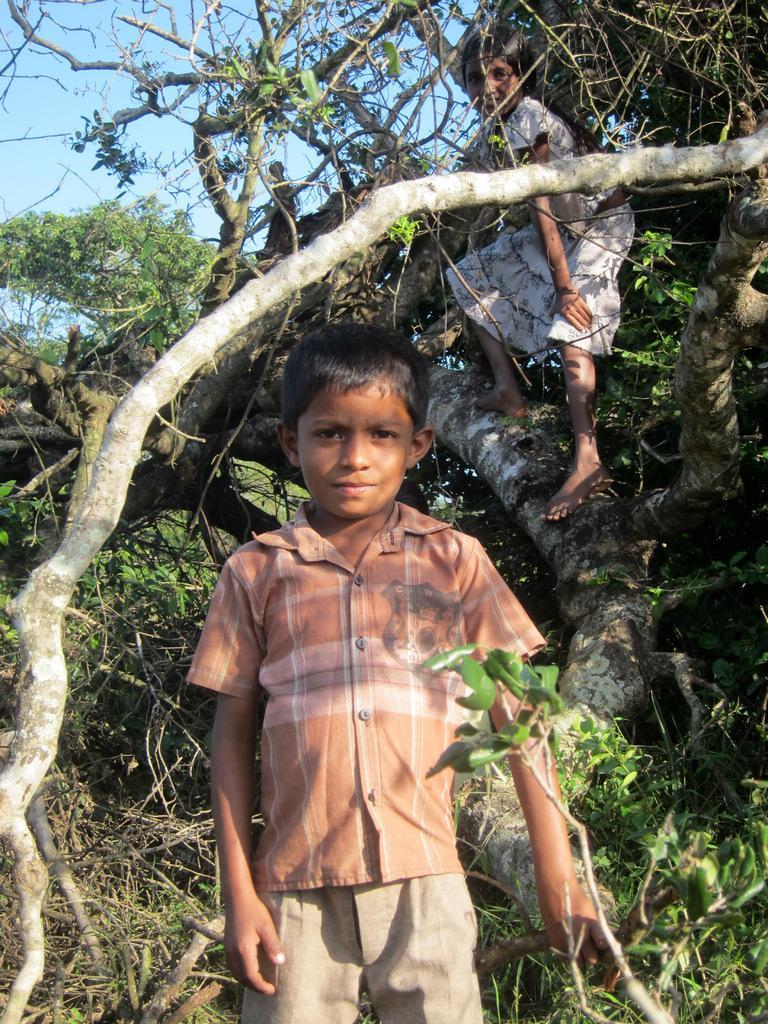Could you give a brief overview of what you see in this image? In this picture we can see a boy and a girl, she is standing on the tree, in the background we can see few trees. 